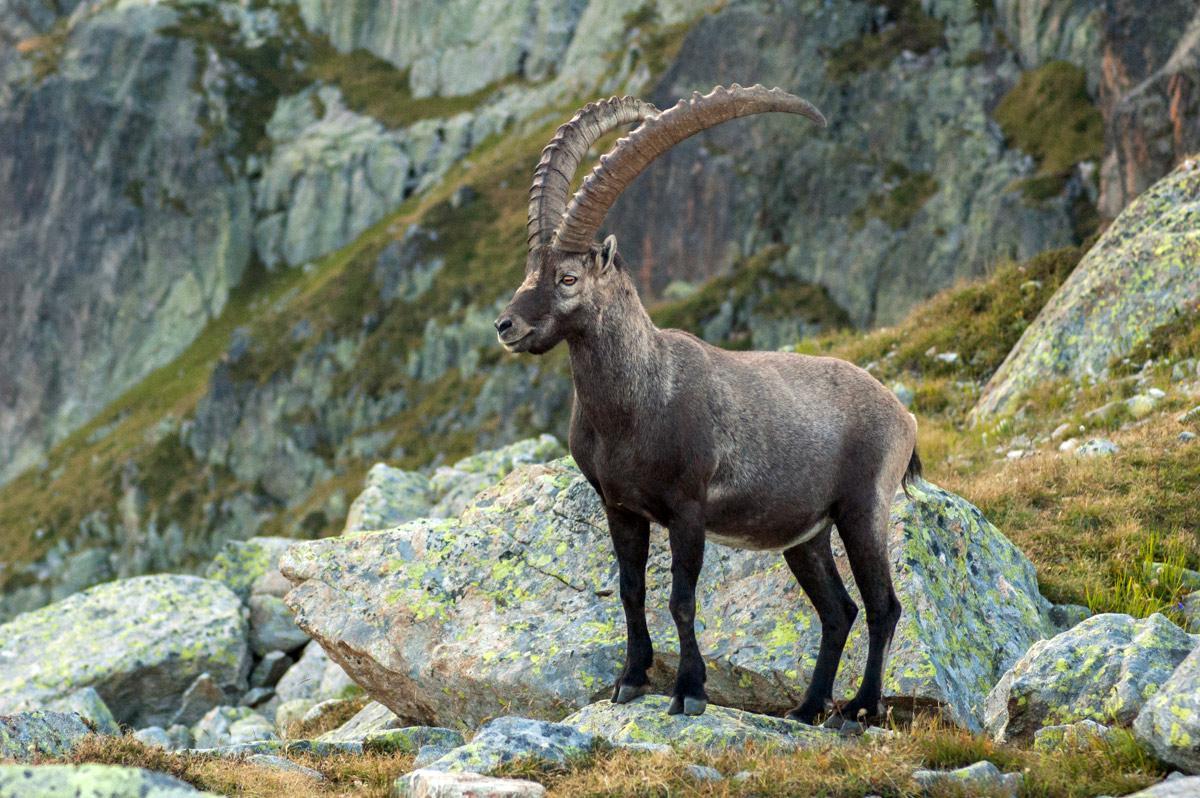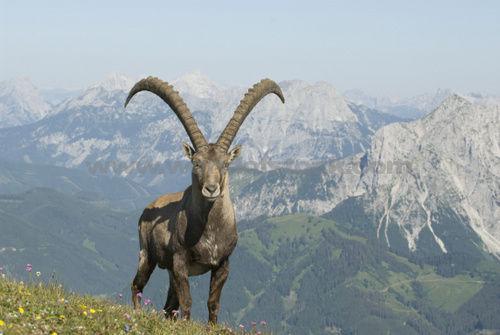The first image is the image on the left, the second image is the image on the right. For the images displayed, is the sentence "Each individual image has exactly one animal in it." factually correct? Answer yes or no. Yes. The first image is the image on the left, the second image is the image on the right. Examine the images to the left and right. Is the description "there are two sheep in the image pair" accurate? Answer yes or no. Yes. 